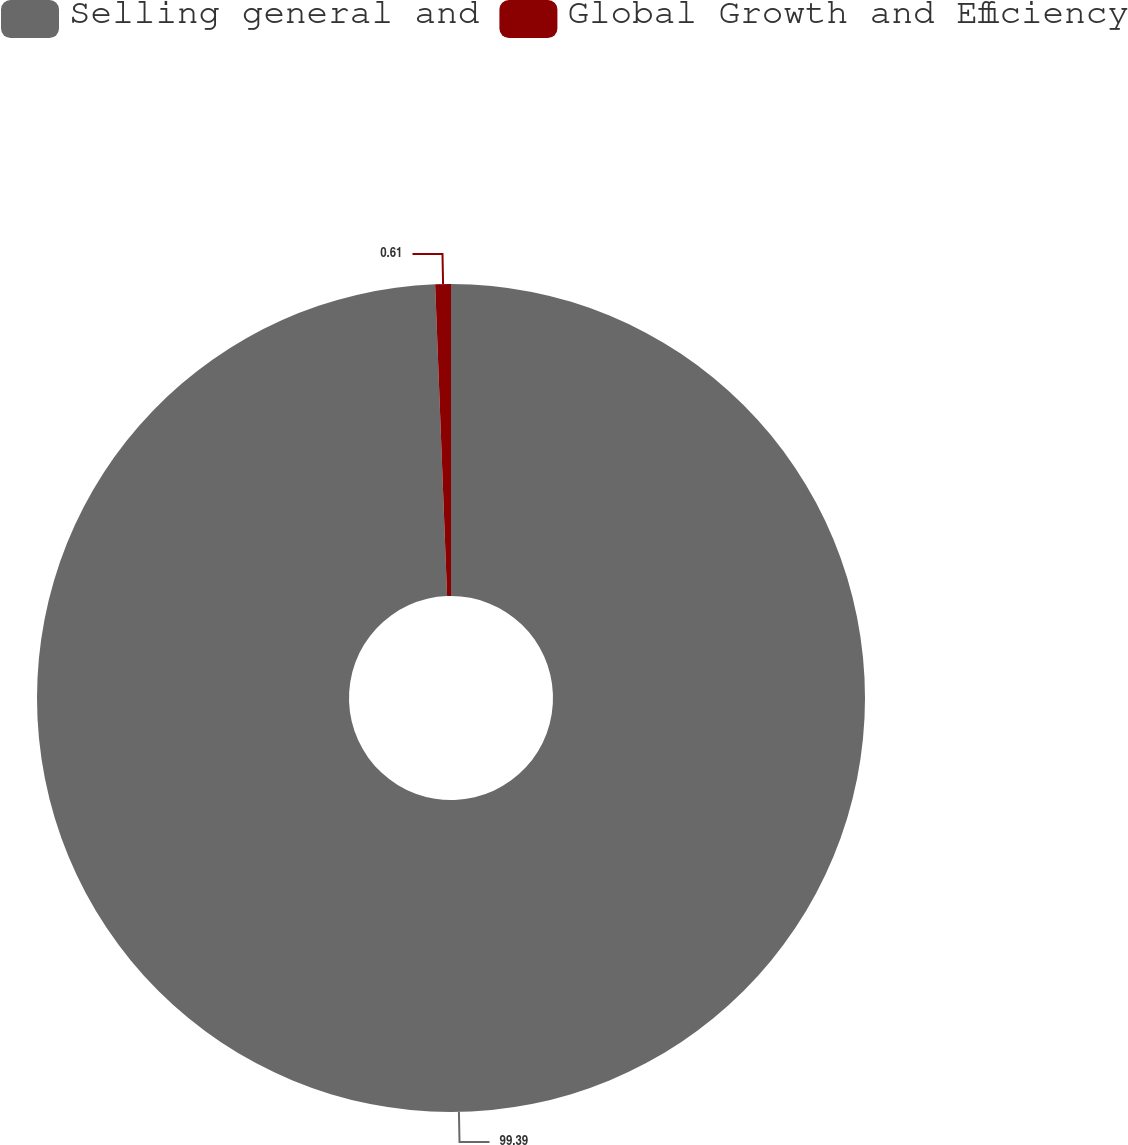<chart> <loc_0><loc_0><loc_500><loc_500><pie_chart><fcel>Selling general and<fcel>Global Growth and Efficiency<nl><fcel>99.39%<fcel>0.61%<nl></chart> 